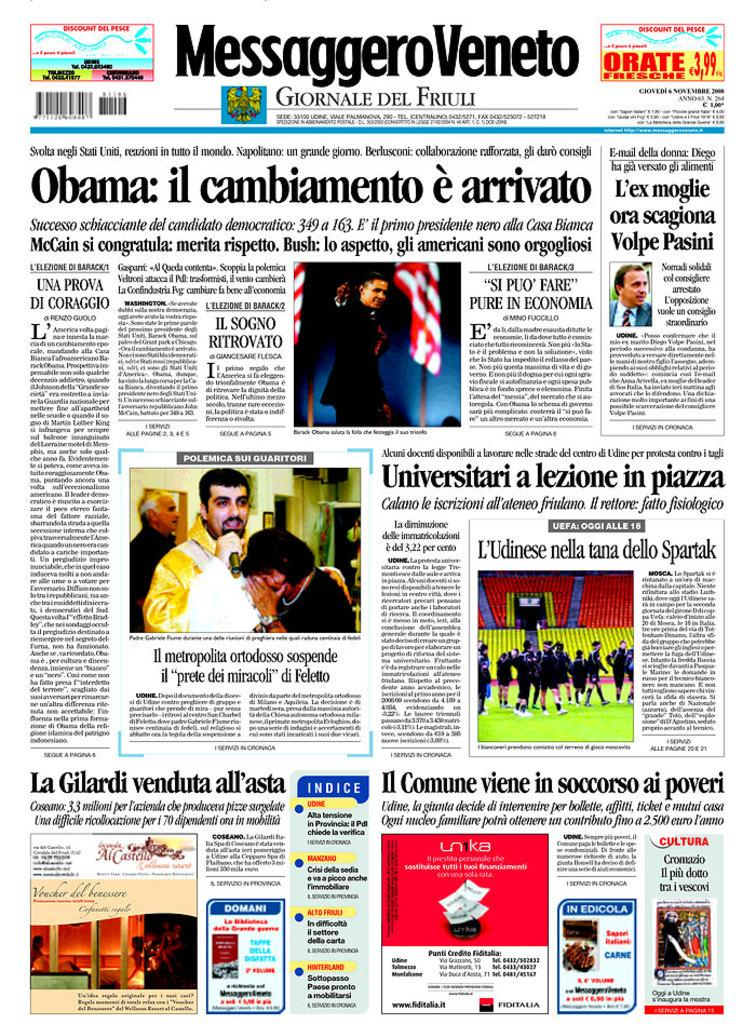What is the main object in the image? The image contains a newspaper. What can be found on the newspaper? There is writing on the newspaper, and it has pictures of people. Are there any identifiable markings on the newspaper? Yes, there are barcodes visible on the newspaper, and it has a logo. What else is present in the image besides the newspaper? There are flags in the image. What direction is the train moving in the image? There is no train present in the image; it only contains a newspaper and flags. What type of destruction can be seen in the image? There is no destruction present in the image; it features a newspaper and flags. 